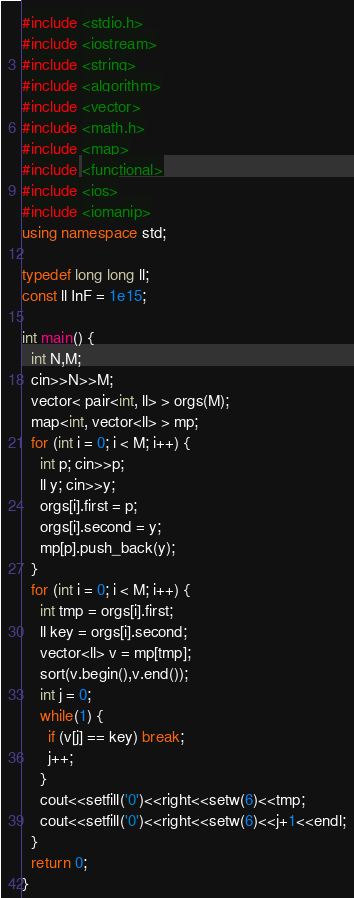Convert code to text. <code><loc_0><loc_0><loc_500><loc_500><_C++_>#include <stdio.h>
#include <iostream>
#include <string>
#include <algorithm>
#include <vector>
#include <math.h>
#include <map>
#include <functional>
#include <ios>
#include <iomanip>
using namespace std;

typedef long long ll;
const ll InF = 1e15;

int main() {
  int N,M;
  cin>>N>>M;
  vector< pair<int, ll> > orgs(M);
  map<int, vector<ll> > mp;
  for (int i = 0; i < M; i++) {
    int p; cin>>p;
    ll y; cin>>y;
    orgs[i].first = p;
    orgs[i].second = y;
    mp[p].push_back(y);
  }
  for (int i = 0; i < M; i++) {
    int tmp = orgs[i].first;
    ll key = orgs[i].second;
    vector<ll> v = mp[tmp];
    sort(v.begin(),v.end());
    int j = 0;
    while(1) {
      if (v[j] == key) break;
      j++;
    }
    cout<<setfill('0')<<right<<setw(6)<<tmp;
    cout<<setfill('0')<<right<<setw(6)<<j+1<<endl;
  }
  return 0;
}</code> 